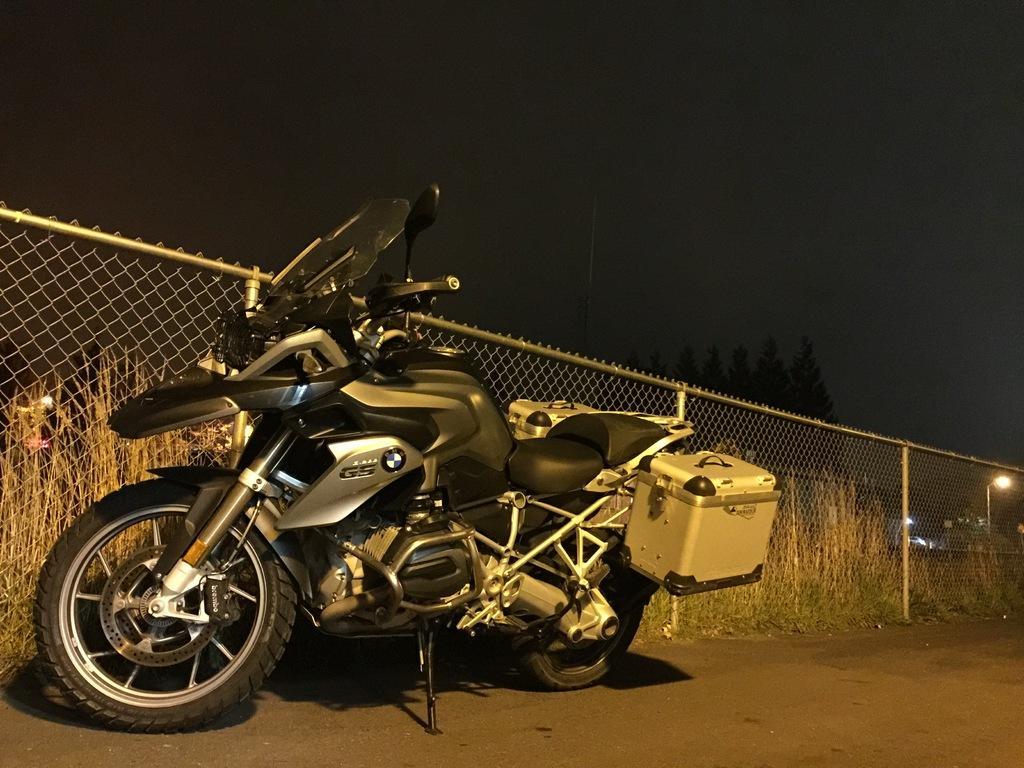Please provide a concise description of this image. This is an image clicked in the dark. Here I can see a bike on the road. At the back of it there is a net fencing and some plants. On the right side there is a street light. 